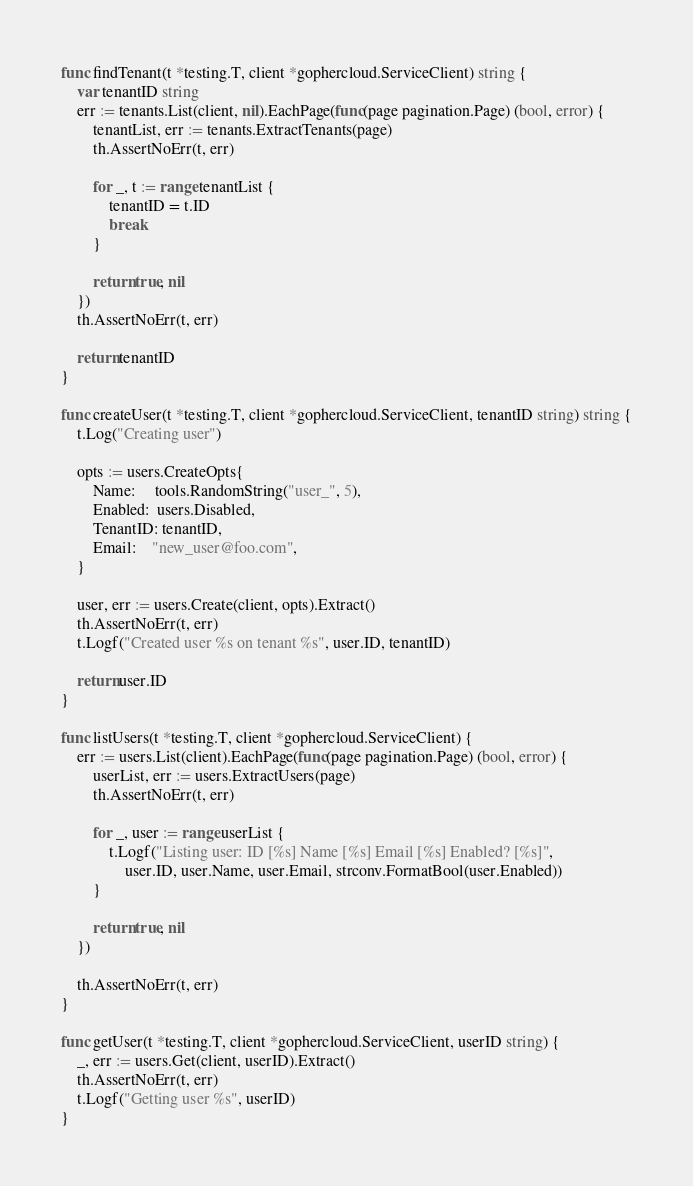Convert code to text. <code><loc_0><loc_0><loc_500><loc_500><_Go_>
func findTenant(t *testing.T, client *gophercloud.ServiceClient) string {
	var tenantID string
	err := tenants.List(client, nil).EachPage(func(page pagination.Page) (bool, error) {
		tenantList, err := tenants.ExtractTenants(page)
		th.AssertNoErr(t, err)

		for _, t := range tenantList {
			tenantID = t.ID
			break
		}

		return true, nil
	})
	th.AssertNoErr(t, err)

	return tenantID
}

func createUser(t *testing.T, client *gophercloud.ServiceClient, tenantID string) string {
	t.Log("Creating user")

	opts := users.CreateOpts{
		Name:     tools.RandomString("user_", 5),
		Enabled:  users.Disabled,
		TenantID: tenantID,
		Email:    "new_user@foo.com",
	}

	user, err := users.Create(client, opts).Extract()
	th.AssertNoErr(t, err)
	t.Logf("Created user %s on tenant %s", user.ID, tenantID)

	return user.ID
}

func listUsers(t *testing.T, client *gophercloud.ServiceClient) {
	err := users.List(client).EachPage(func(page pagination.Page) (bool, error) {
		userList, err := users.ExtractUsers(page)
		th.AssertNoErr(t, err)

		for _, user := range userList {
			t.Logf("Listing user: ID [%s] Name [%s] Email [%s] Enabled? [%s]",
				user.ID, user.Name, user.Email, strconv.FormatBool(user.Enabled))
		}

		return true, nil
	})

	th.AssertNoErr(t, err)
}

func getUser(t *testing.T, client *gophercloud.ServiceClient, userID string) {
	_, err := users.Get(client, userID).Extract()
	th.AssertNoErr(t, err)
	t.Logf("Getting user %s", userID)
}
</code> 